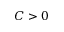<formula> <loc_0><loc_0><loc_500><loc_500>C > 0</formula> 